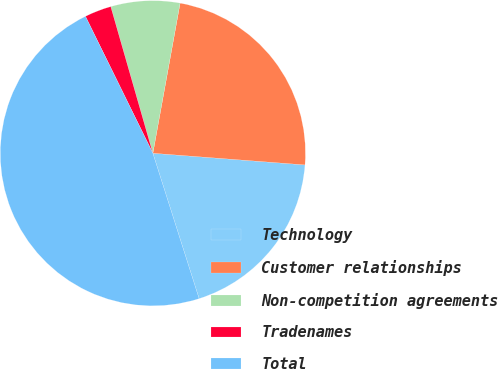Convert chart to OTSL. <chart><loc_0><loc_0><loc_500><loc_500><pie_chart><fcel>Technology<fcel>Customer relationships<fcel>Non-competition agreements<fcel>Tradenames<fcel>Total<nl><fcel>18.88%<fcel>23.36%<fcel>7.31%<fcel>2.83%<fcel>47.62%<nl></chart> 